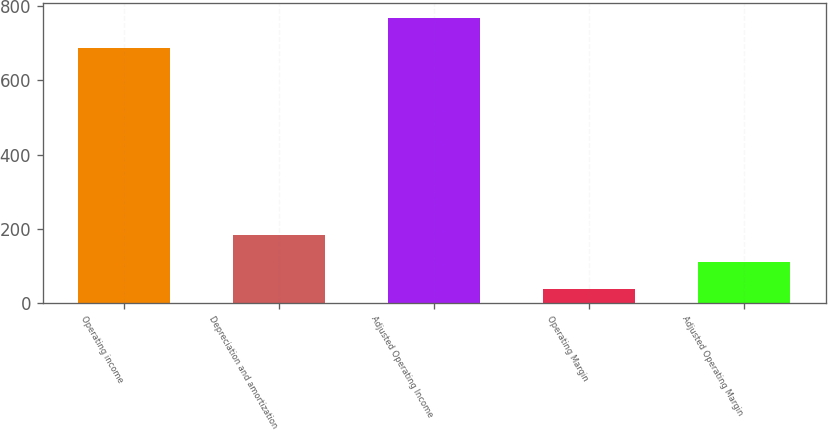Convert chart to OTSL. <chart><loc_0><loc_0><loc_500><loc_500><bar_chart><fcel>Operating income<fcel>Depreciation and amortization<fcel>Adjusted Operating Income<fcel>Operating Margin<fcel>Adjusted Operating Margin<nl><fcel>687.5<fcel>184.46<fcel>769.1<fcel>38.3<fcel>111.38<nl></chart> 